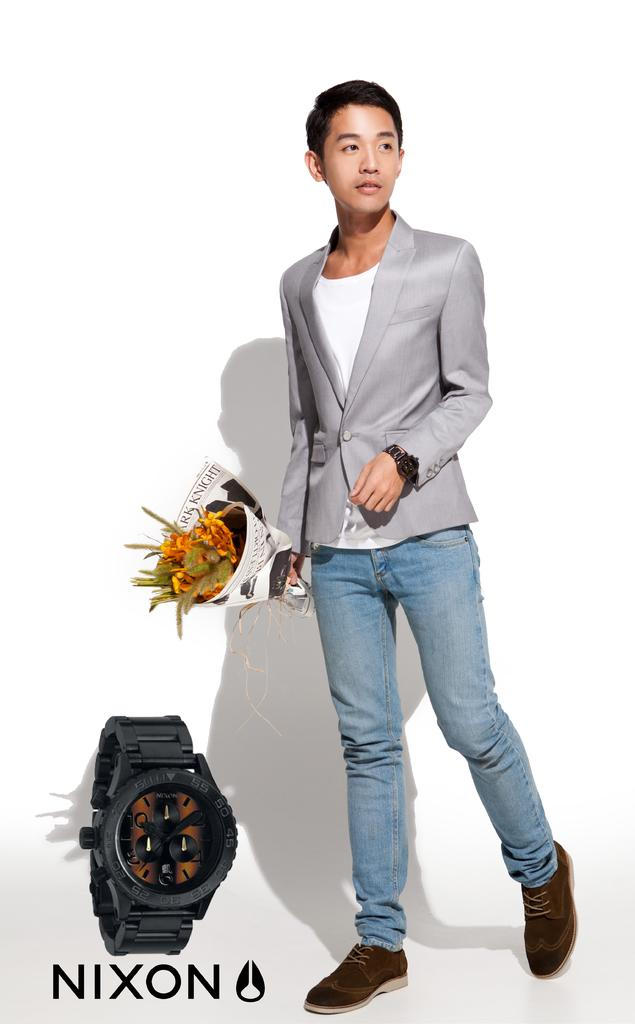<image>
Present a compact description of the photo's key features. Advertisement for Nixon watch featuring man in blazer and jeans holding flowers, with watch at lower left corner. 